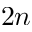<formula> <loc_0><loc_0><loc_500><loc_500>2 n</formula> 